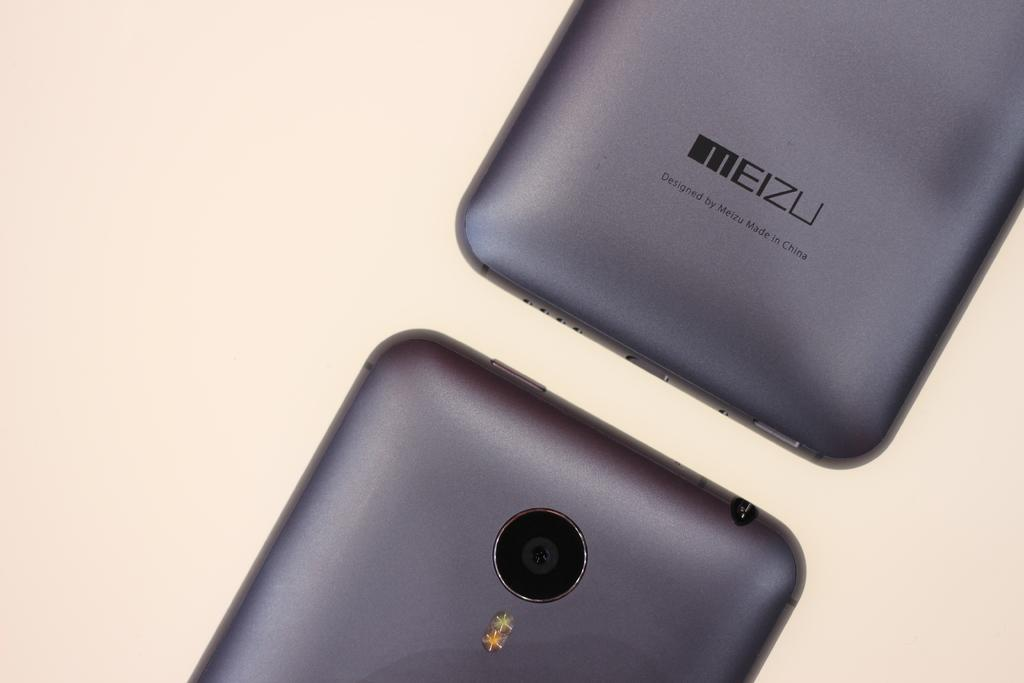<image>
Offer a succinct explanation of the picture presented. A meizli logo can be seen on the back of a black device. 